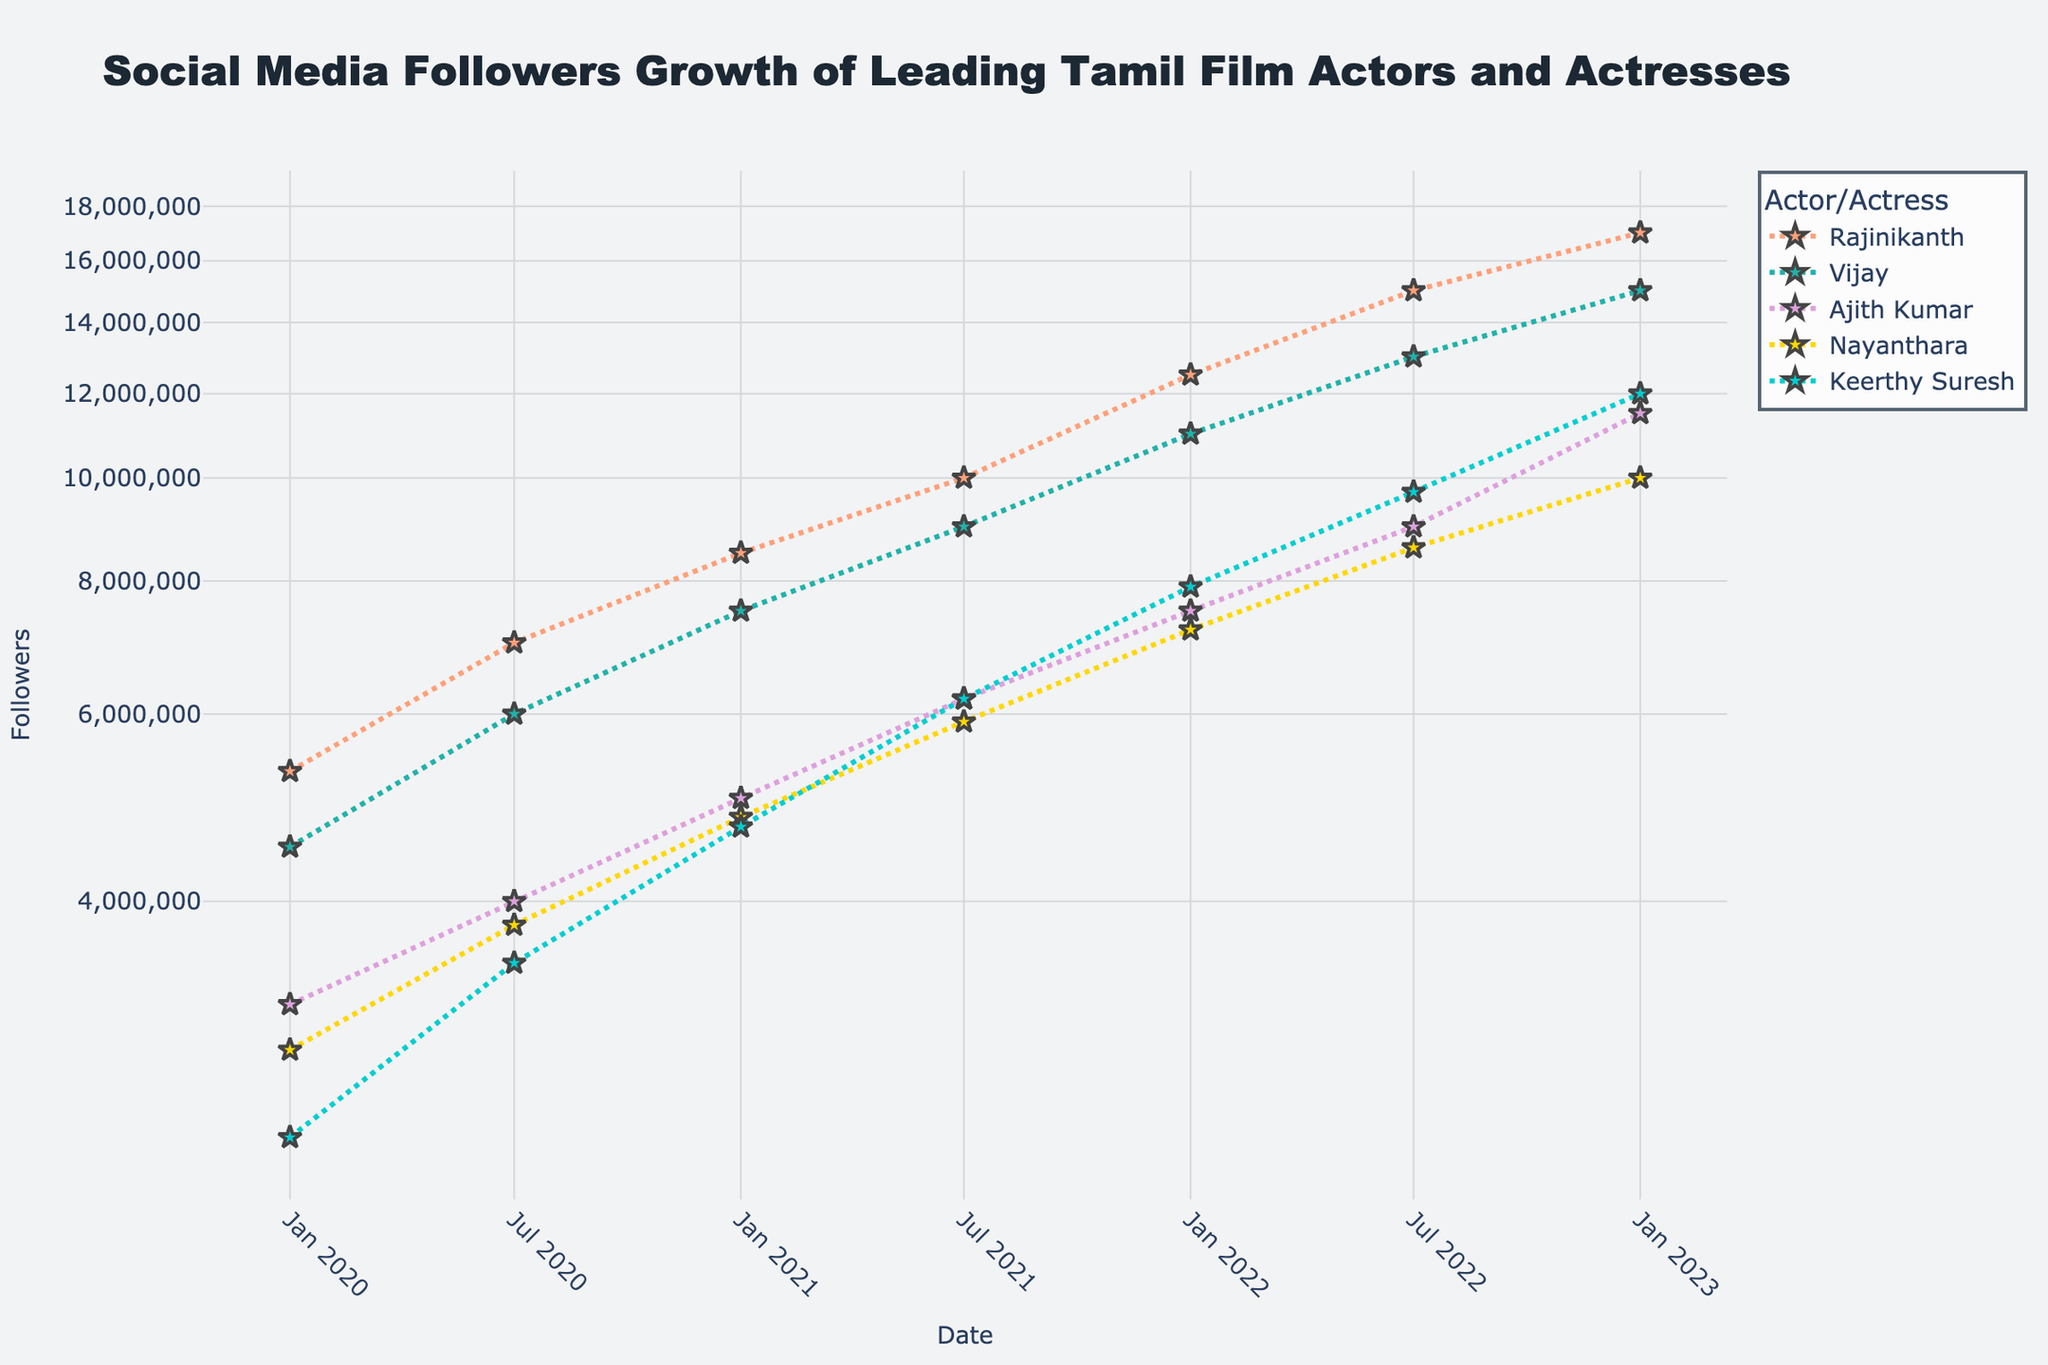What is the title of the scatter plot? The title of the scatter plot is found at the top center of the figure. It describes the key information the plot is presenting, which is the growth of social media followers over time for Tamil film actors and actresses.
Answer: Social Media Followers Growth of Leading Tamil Film Actors and Actresses How are the dates displayed on the x-axis? The x-axis represents time and the dates are displayed with a slight angle for clarity. Each date marks a data point corresponding to different times of measurement.
Answer: Angled How many actors and actresses are presented in the scatter plot? The scatter plot uses different colored lines and markers to represent various actors and actresses. By looking at the legend, you can determine the total number of unique individuals.
Answer: 5 Which actor/actress had the highest number of followers in January 2023? By examining the end points of each line on the plot, closest to January 2023 on the x-axis, you can identify the actor/actress with the highest y-axis value for followers.
Answer: Rajinikanth Between January 2020 and January 2023, which actor/actress had the largest increase in followers? Calculate the difference in followers between January 2020 and January 2023 for each actor/actress represented on the plot. The actor/actress with the highest difference will be the answer.
Answer: Rajinikanth Who had more followers in July 2021, Nayanthara or Keerthy Suresh? Locate the data points for Nayanthara and Keerthy Suresh at July 2021 on the x-axis and compare their y-axis values (followers).
Answer: Keerthy Suresh What is the general trend in followers for all actors and actresses over time? Observe the direction and steepness of the lines representing each individual. This tells you how the number of followers changes over time.
Answer: Increasing Which actor/actress had the most rapid growth in followers between July 2022 and January 2023? Identify the steepness of the lines between these two points on the x-axis. The steeper the line, the more rapid the growth.
Answer: Ajith Kumar What does the log scale on the y-axis represent in this scatter plot? The log scale is used to present a wide range of values in a more readable way, indicating exponential growth patterns in followers.
Answer: Exponential growth Compare the follower counts of Vijay and Rajinikanth in July 2020. Locate the July 2020 data points for both Vijay and Rajinikanth on the x-axis and compare their y-axis values.
Answer: Rajinikanth 